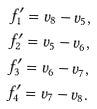Convert formula to latex. <formula><loc_0><loc_0><loc_500><loc_500>f ^ { \prime } _ { 1 } & = v _ { 8 } - v _ { 5 } , \\ f ^ { \prime } _ { 2 } & = v _ { 5 } - v _ { 6 } , \\ f ^ { \prime } _ { 3 } & = v _ { 6 } - v _ { 7 } , \\ f ^ { \prime } _ { 4 } & = v _ { 7 } - v _ { 8 } .</formula> 